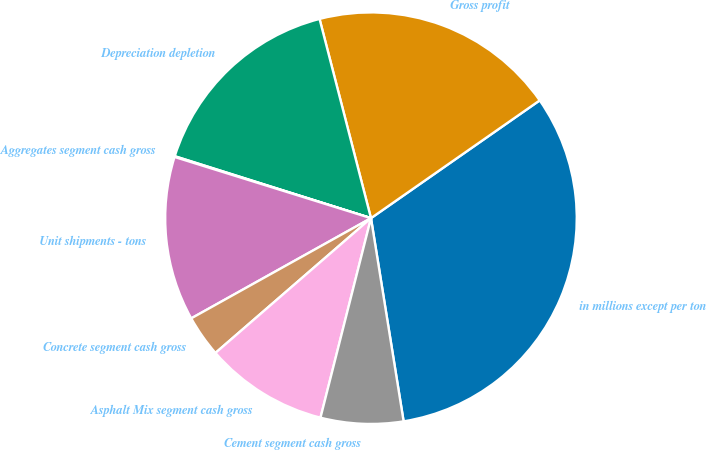<chart> <loc_0><loc_0><loc_500><loc_500><pie_chart><fcel>in millions except per ton<fcel>Gross profit<fcel>Depreciation depletion<fcel>Aggregates segment cash gross<fcel>Unit shipments - tons<fcel>Concrete segment cash gross<fcel>Asphalt Mix segment cash gross<fcel>Cement segment cash gross<nl><fcel>32.16%<fcel>19.32%<fcel>16.11%<fcel>0.06%<fcel>12.9%<fcel>3.27%<fcel>9.69%<fcel>6.48%<nl></chart> 